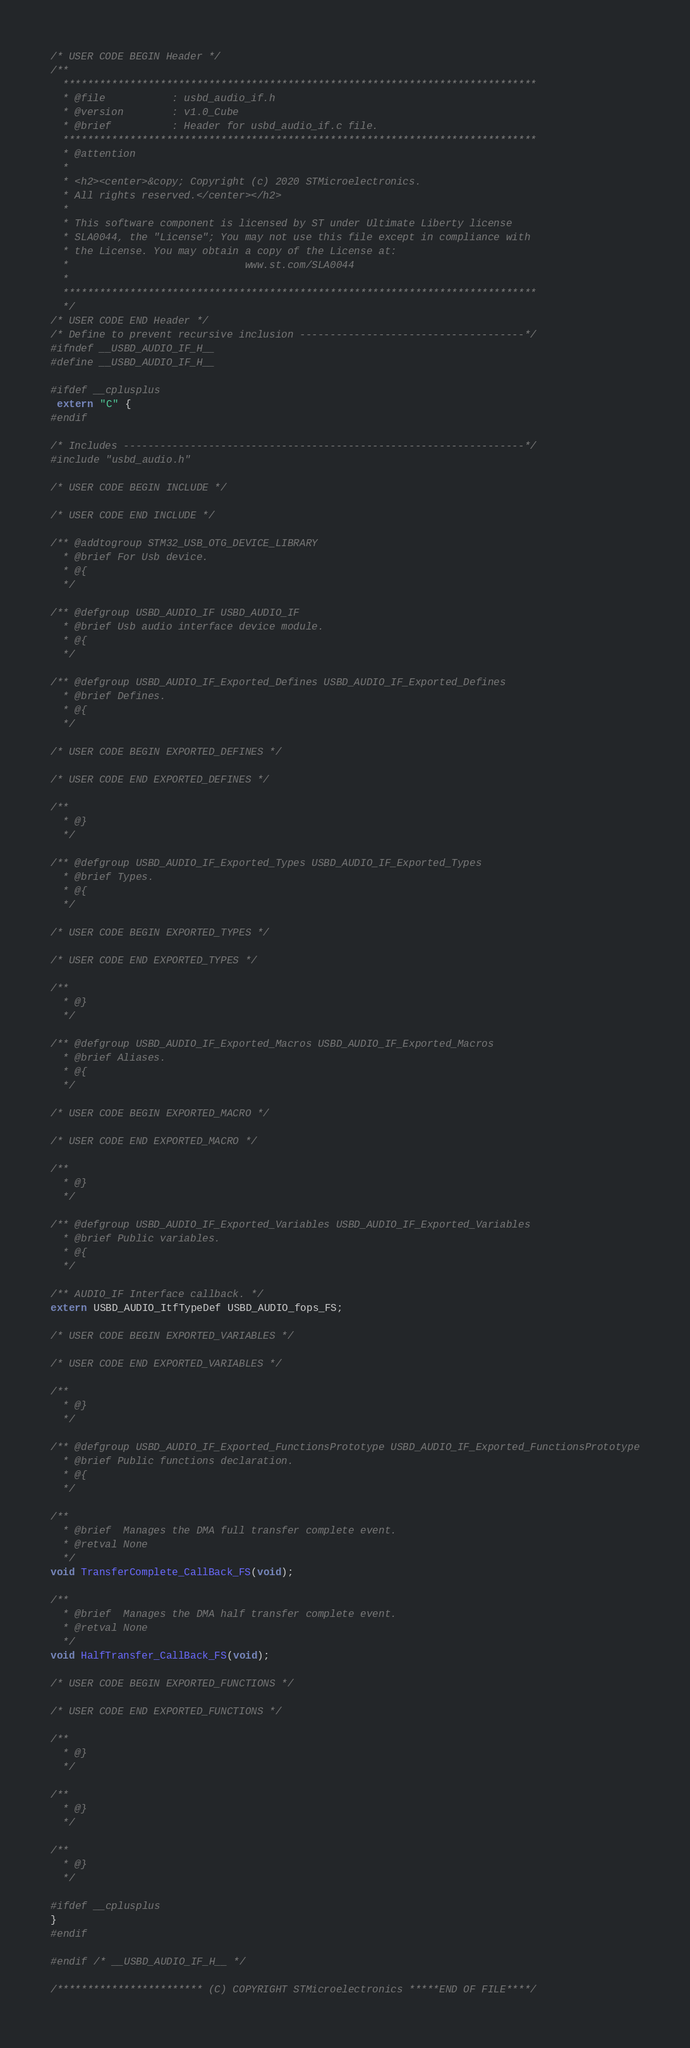Convert code to text. <code><loc_0><loc_0><loc_500><loc_500><_C_>/* USER CODE BEGIN Header */
/**
  ******************************************************************************
  * @file           : usbd_audio_if.h
  * @version        : v1.0_Cube
  * @brief          : Header for usbd_audio_if.c file.
  ******************************************************************************
  * @attention
  *
  * <h2><center>&copy; Copyright (c) 2020 STMicroelectronics.
  * All rights reserved.</center></h2>
  *
  * This software component is licensed by ST under Ultimate Liberty license
  * SLA0044, the "License"; You may not use this file except in compliance with
  * the License. You may obtain a copy of the License at:
  *                             www.st.com/SLA0044
  *
  ******************************************************************************
  */
/* USER CODE END Header */
/* Define to prevent recursive inclusion -------------------------------------*/
#ifndef __USBD_AUDIO_IF_H__
#define __USBD_AUDIO_IF_H__

#ifdef __cplusplus
 extern "C" {
#endif

/* Includes ------------------------------------------------------------------*/
#include "usbd_audio.h"

/* USER CODE BEGIN INCLUDE */

/* USER CODE END INCLUDE */

/** @addtogroup STM32_USB_OTG_DEVICE_LIBRARY
  * @brief For Usb device.
  * @{
  */

/** @defgroup USBD_AUDIO_IF USBD_AUDIO_IF
  * @brief Usb audio interface device module.
  * @{
  */

/** @defgroup USBD_AUDIO_IF_Exported_Defines USBD_AUDIO_IF_Exported_Defines
  * @brief Defines.
  * @{
  */

/* USER CODE BEGIN EXPORTED_DEFINES */

/* USER CODE END EXPORTED_DEFINES */

/**
  * @}
  */

/** @defgroup USBD_AUDIO_IF_Exported_Types USBD_AUDIO_IF_Exported_Types
  * @brief Types.
  * @{
  */

/* USER CODE BEGIN EXPORTED_TYPES */

/* USER CODE END EXPORTED_TYPES */

/**
  * @}
  */

/** @defgroup USBD_AUDIO_IF_Exported_Macros USBD_AUDIO_IF_Exported_Macros
  * @brief Aliases.
  * @{
  */

/* USER CODE BEGIN EXPORTED_MACRO */

/* USER CODE END EXPORTED_MACRO */

/**
  * @}
  */

/** @defgroup USBD_AUDIO_IF_Exported_Variables USBD_AUDIO_IF_Exported_Variables
  * @brief Public variables.
  * @{
  */

/** AUDIO_IF Interface callback. */
extern USBD_AUDIO_ItfTypeDef USBD_AUDIO_fops_FS;

/* USER CODE BEGIN EXPORTED_VARIABLES */

/* USER CODE END EXPORTED_VARIABLES */

/**
  * @}
  */

/** @defgroup USBD_AUDIO_IF_Exported_FunctionsPrototype USBD_AUDIO_IF_Exported_FunctionsPrototype
  * @brief Public functions declaration.
  * @{
  */

/**
  * @brief  Manages the DMA full transfer complete event.
  * @retval None
  */
void TransferComplete_CallBack_FS(void);

/**
  * @brief  Manages the DMA half transfer complete event.
  * @retval None
  */
void HalfTransfer_CallBack_FS(void);

/* USER CODE BEGIN EXPORTED_FUNCTIONS */

/* USER CODE END EXPORTED_FUNCTIONS */

/**
  * @}
  */

/**
  * @}
  */

/**
  * @}
  */

#ifdef __cplusplus
}
#endif

#endif /* __USBD_AUDIO_IF_H__ */

/************************ (C) COPYRIGHT STMicroelectronics *****END OF FILE****/
</code> 